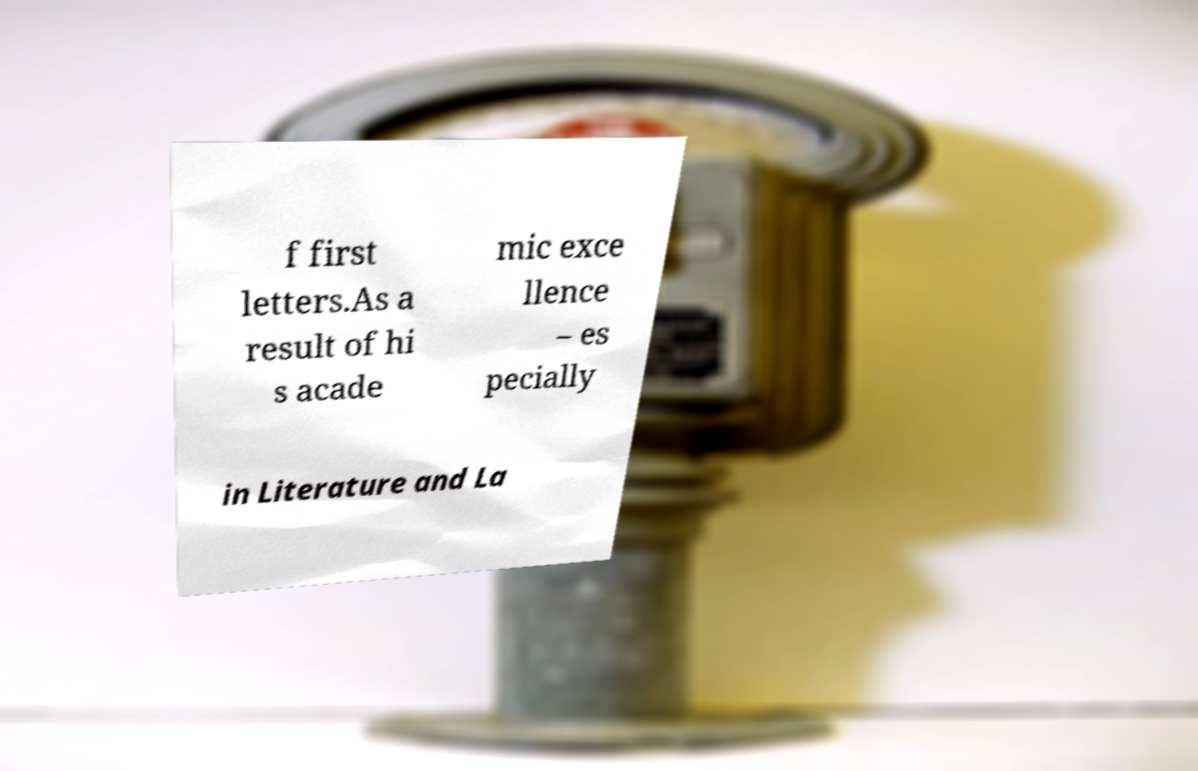Could you extract and type out the text from this image? f first letters.As a result of hi s acade mic exce llence – es pecially in Literature and La 